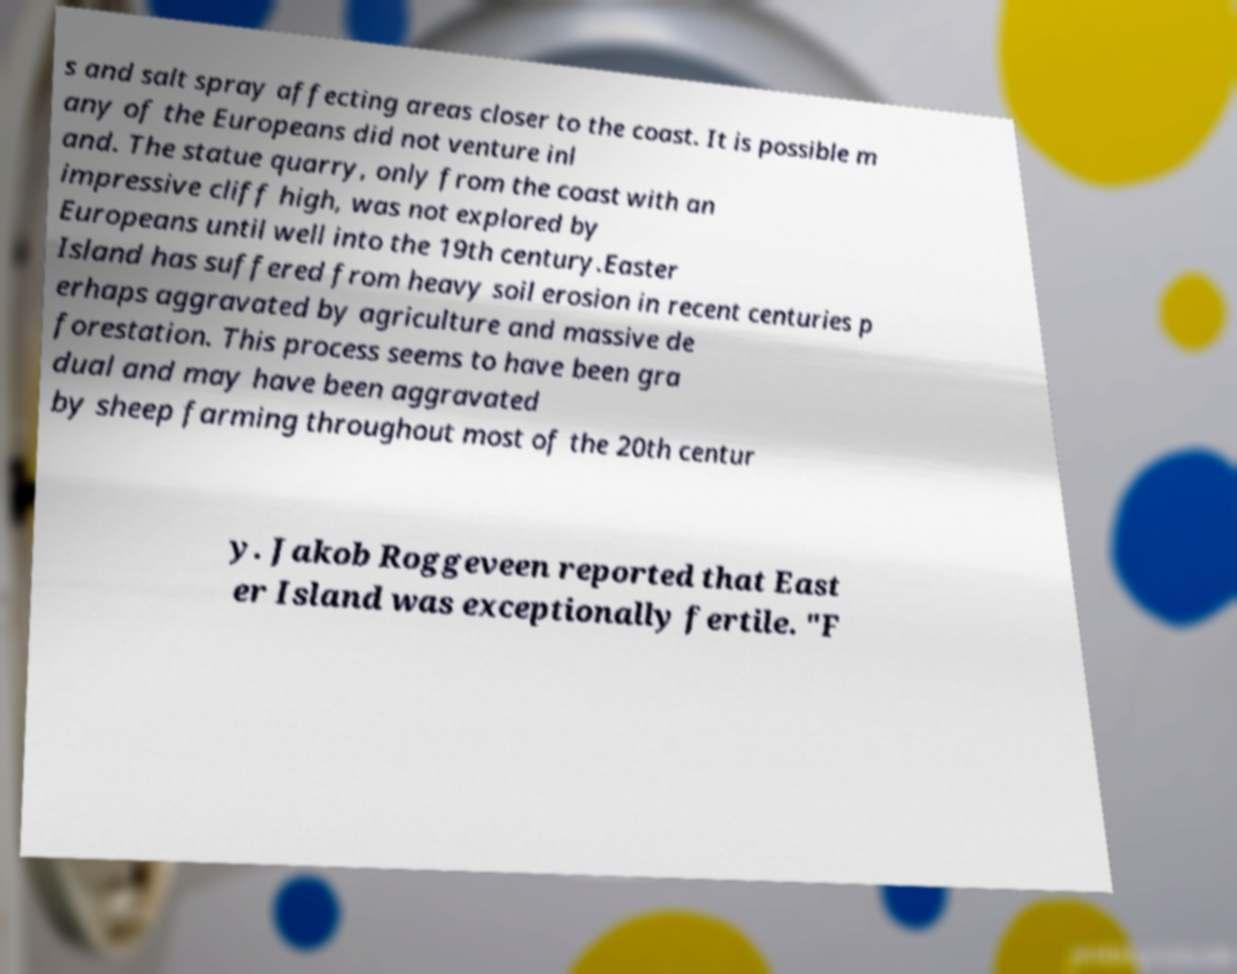There's text embedded in this image that I need extracted. Can you transcribe it verbatim? s and salt spray affecting areas closer to the coast. It is possible m any of the Europeans did not venture inl and. The statue quarry, only from the coast with an impressive cliff high, was not explored by Europeans until well into the 19th century.Easter Island has suffered from heavy soil erosion in recent centuries p erhaps aggravated by agriculture and massive de forestation. This process seems to have been gra dual and may have been aggravated by sheep farming throughout most of the 20th centur y. Jakob Roggeveen reported that East er Island was exceptionally fertile. "F 